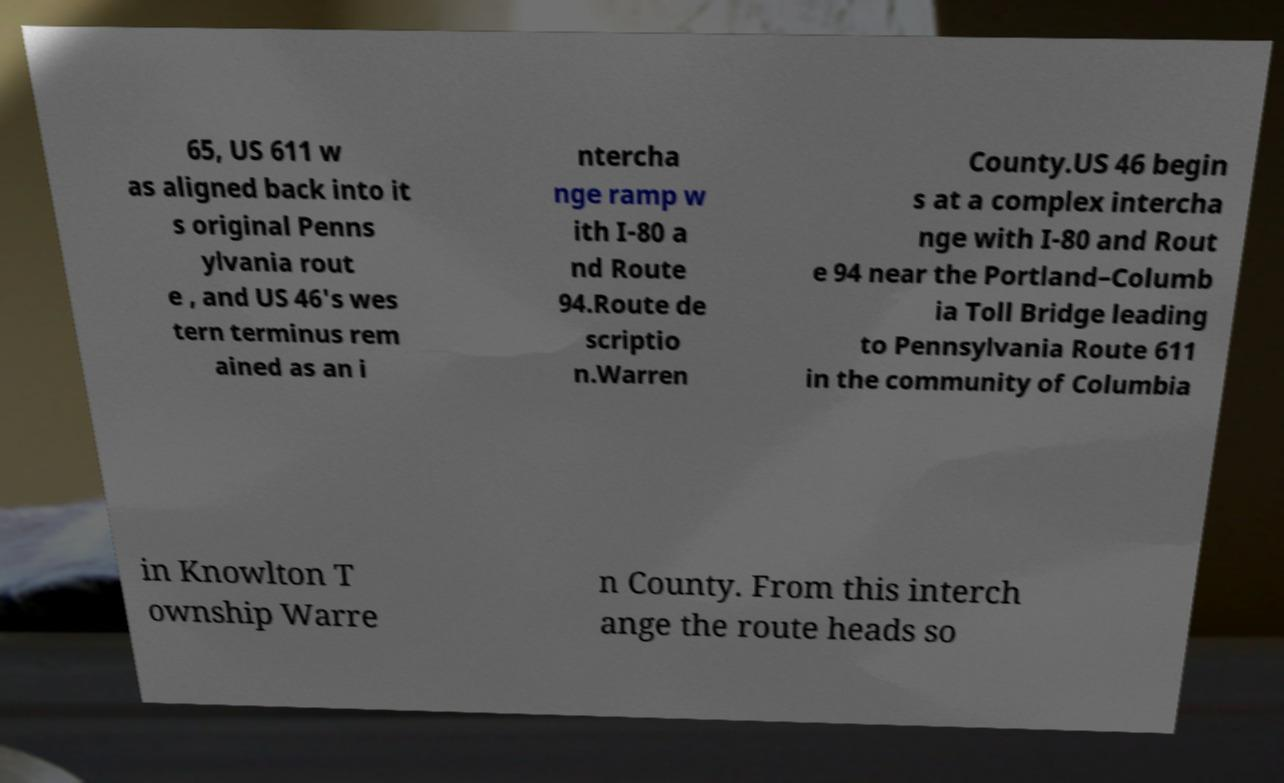Can you read and provide the text displayed in the image?This photo seems to have some interesting text. Can you extract and type it out for me? 65, US 611 w as aligned back into it s original Penns ylvania rout e , and US 46's wes tern terminus rem ained as an i ntercha nge ramp w ith I-80 a nd Route 94.Route de scriptio n.Warren County.US 46 begin s at a complex intercha nge with I-80 and Rout e 94 near the Portland–Columb ia Toll Bridge leading to Pennsylvania Route 611 in the community of Columbia in Knowlton T ownship Warre n County. From this interch ange the route heads so 